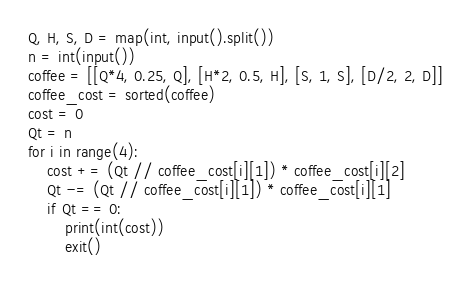Convert code to text. <code><loc_0><loc_0><loc_500><loc_500><_Python_>Q, H, S, D = map(int, input().split())
n = int(input())
coffee = [[Q*4, 0.25, Q], [H*2, 0.5, H], [S, 1, S], [D/2, 2, D]]
coffee_cost = sorted(coffee)
cost = 0
Qt = n
for i in range(4):
    cost += (Qt // coffee_cost[i][1]) * coffee_cost[i][2]
    Qt -= (Qt // coffee_cost[i][1]) * coffee_cost[i][1]
    if Qt == 0:
        print(int(cost))
        exit()</code> 